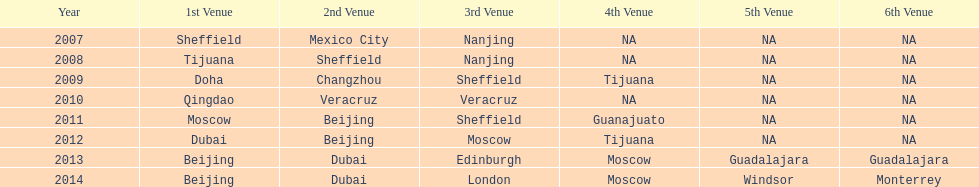Name a year whose second venue was the same as 2011. 2012. 